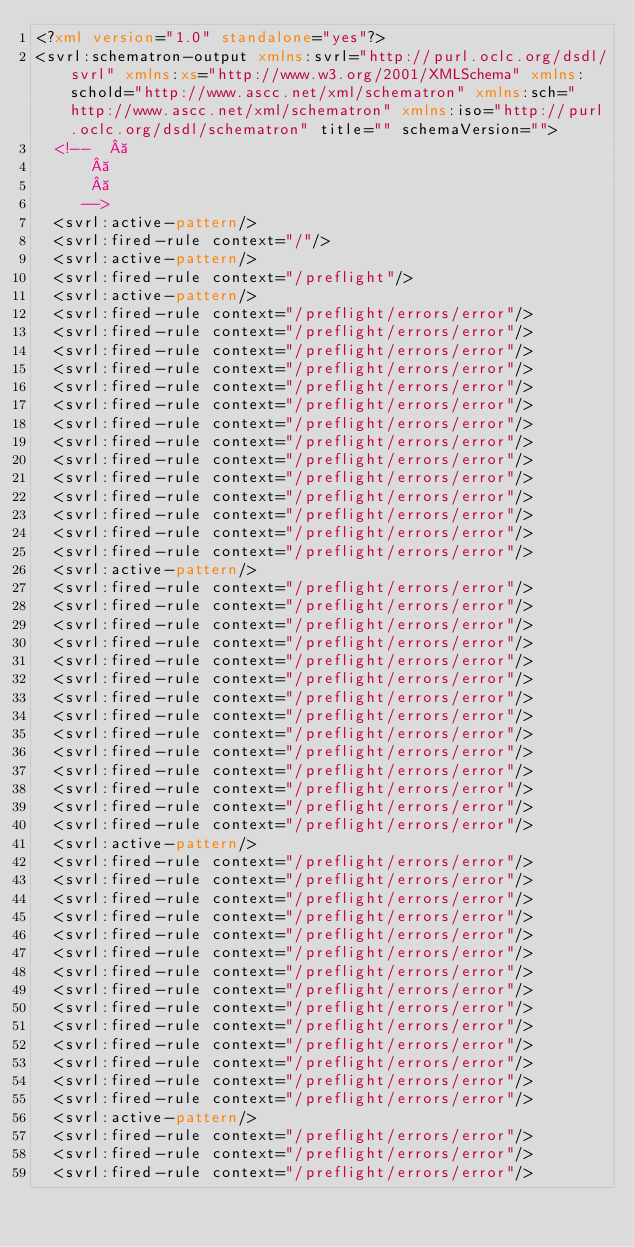<code> <loc_0><loc_0><loc_500><loc_500><_XML_><?xml version="1.0" standalone="yes"?>
<svrl:schematron-output xmlns:svrl="http://purl.oclc.org/dsdl/svrl" xmlns:xs="http://www.w3.org/2001/XMLSchema" xmlns:schold="http://www.ascc.net/xml/schematron" xmlns:sch="http://www.ascc.net/xml/schematron" xmlns:iso="http://purl.oclc.org/dsdl/schematron" title="" schemaVersion="">
  <!--   
		   
		   
		 -->
  <svrl:active-pattern/>
  <svrl:fired-rule context="/"/>
  <svrl:active-pattern/>
  <svrl:fired-rule context="/preflight"/>
  <svrl:active-pattern/>
  <svrl:fired-rule context="/preflight/errors/error"/>
  <svrl:fired-rule context="/preflight/errors/error"/>
  <svrl:fired-rule context="/preflight/errors/error"/>
  <svrl:fired-rule context="/preflight/errors/error"/>
  <svrl:fired-rule context="/preflight/errors/error"/>
  <svrl:fired-rule context="/preflight/errors/error"/>
  <svrl:fired-rule context="/preflight/errors/error"/>
  <svrl:fired-rule context="/preflight/errors/error"/>
  <svrl:fired-rule context="/preflight/errors/error"/>
  <svrl:fired-rule context="/preflight/errors/error"/>
  <svrl:fired-rule context="/preflight/errors/error"/>
  <svrl:fired-rule context="/preflight/errors/error"/>
  <svrl:fired-rule context="/preflight/errors/error"/>
  <svrl:fired-rule context="/preflight/errors/error"/>
  <svrl:active-pattern/>
  <svrl:fired-rule context="/preflight/errors/error"/>
  <svrl:fired-rule context="/preflight/errors/error"/>
  <svrl:fired-rule context="/preflight/errors/error"/>
  <svrl:fired-rule context="/preflight/errors/error"/>
  <svrl:fired-rule context="/preflight/errors/error"/>
  <svrl:fired-rule context="/preflight/errors/error"/>
  <svrl:fired-rule context="/preflight/errors/error"/>
  <svrl:fired-rule context="/preflight/errors/error"/>
  <svrl:fired-rule context="/preflight/errors/error"/>
  <svrl:fired-rule context="/preflight/errors/error"/>
  <svrl:fired-rule context="/preflight/errors/error"/>
  <svrl:fired-rule context="/preflight/errors/error"/>
  <svrl:fired-rule context="/preflight/errors/error"/>
  <svrl:fired-rule context="/preflight/errors/error"/>
  <svrl:active-pattern/>
  <svrl:fired-rule context="/preflight/errors/error"/>
  <svrl:fired-rule context="/preflight/errors/error"/>
  <svrl:fired-rule context="/preflight/errors/error"/>
  <svrl:fired-rule context="/preflight/errors/error"/>
  <svrl:fired-rule context="/preflight/errors/error"/>
  <svrl:fired-rule context="/preflight/errors/error"/>
  <svrl:fired-rule context="/preflight/errors/error"/>
  <svrl:fired-rule context="/preflight/errors/error"/>
  <svrl:fired-rule context="/preflight/errors/error"/>
  <svrl:fired-rule context="/preflight/errors/error"/>
  <svrl:fired-rule context="/preflight/errors/error"/>
  <svrl:fired-rule context="/preflight/errors/error"/>
  <svrl:fired-rule context="/preflight/errors/error"/>
  <svrl:fired-rule context="/preflight/errors/error"/>
  <svrl:active-pattern/>
  <svrl:fired-rule context="/preflight/errors/error"/>
  <svrl:fired-rule context="/preflight/errors/error"/>
  <svrl:fired-rule context="/preflight/errors/error"/></code> 